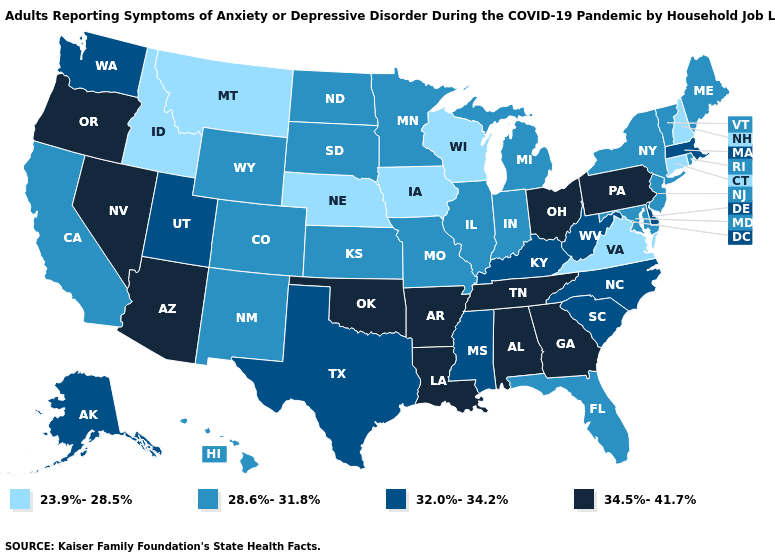Does Missouri have the lowest value in the USA?
Be succinct. No. Does Colorado have a higher value than Iowa?
Quick response, please. Yes. What is the value of New Jersey?
Write a very short answer. 28.6%-31.8%. Does Washington have the lowest value in the USA?
Write a very short answer. No. What is the value of Iowa?
Concise answer only. 23.9%-28.5%. What is the value of Hawaii?
Give a very brief answer. 28.6%-31.8%. Does the first symbol in the legend represent the smallest category?
Give a very brief answer. Yes. Name the states that have a value in the range 28.6%-31.8%?
Answer briefly. California, Colorado, Florida, Hawaii, Illinois, Indiana, Kansas, Maine, Maryland, Michigan, Minnesota, Missouri, New Jersey, New Mexico, New York, North Dakota, Rhode Island, South Dakota, Vermont, Wyoming. Name the states that have a value in the range 32.0%-34.2%?
Be succinct. Alaska, Delaware, Kentucky, Massachusetts, Mississippi, North Carolina, South Carolina, Texas, Utah, Washington, West Virginia. What is the lowest value in the USA?
Answer briefly. 23.9%-28.5%. What is the value of Michigan?
Answer briefly. 28.6%-31.8%. Name the states that have a value in the range 32.0%-34.2%?
Short answer required. Alaska, Delaware, Kentucky, Massachusetts, Mississippi, North Carolina, South Carolina, Texas, Utah, Washington, West Virginia. Does North Carolina have a lower value than Kansas?
Be succinct. No. Does Idaho have the lowest value in the USA?
Quick response, please. Yes. Does Arizona have the lowest value in the USA?
Give a very brief answer. No. 